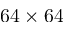<formula> <loc_0><loc_0><loc_500><loc_500>6 4 \times 6 4</formula> 